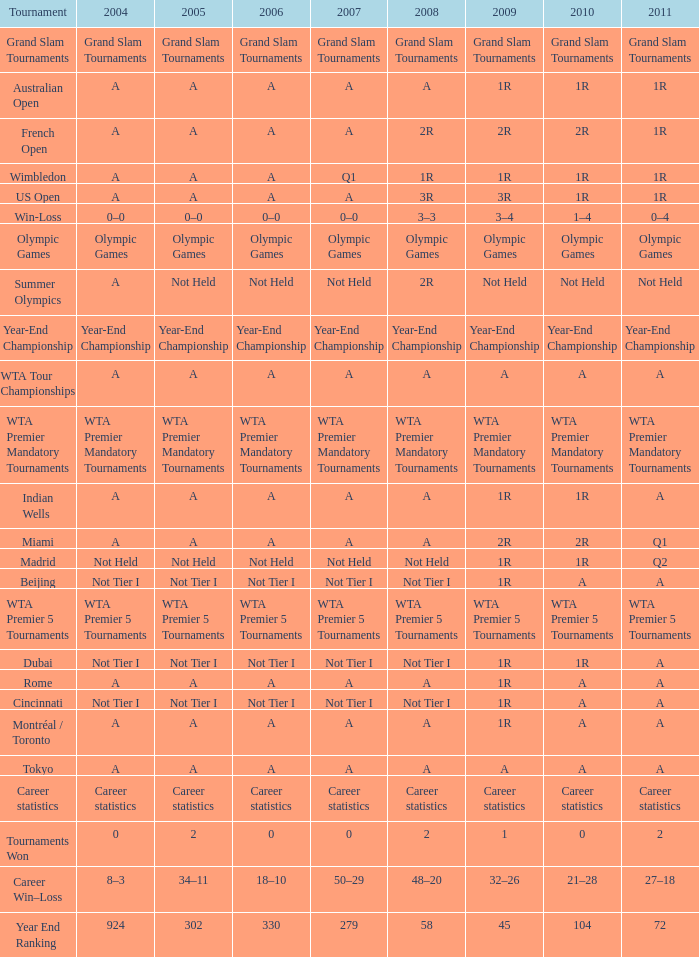What is 2010, when 2009 is "1"? 0.0. 